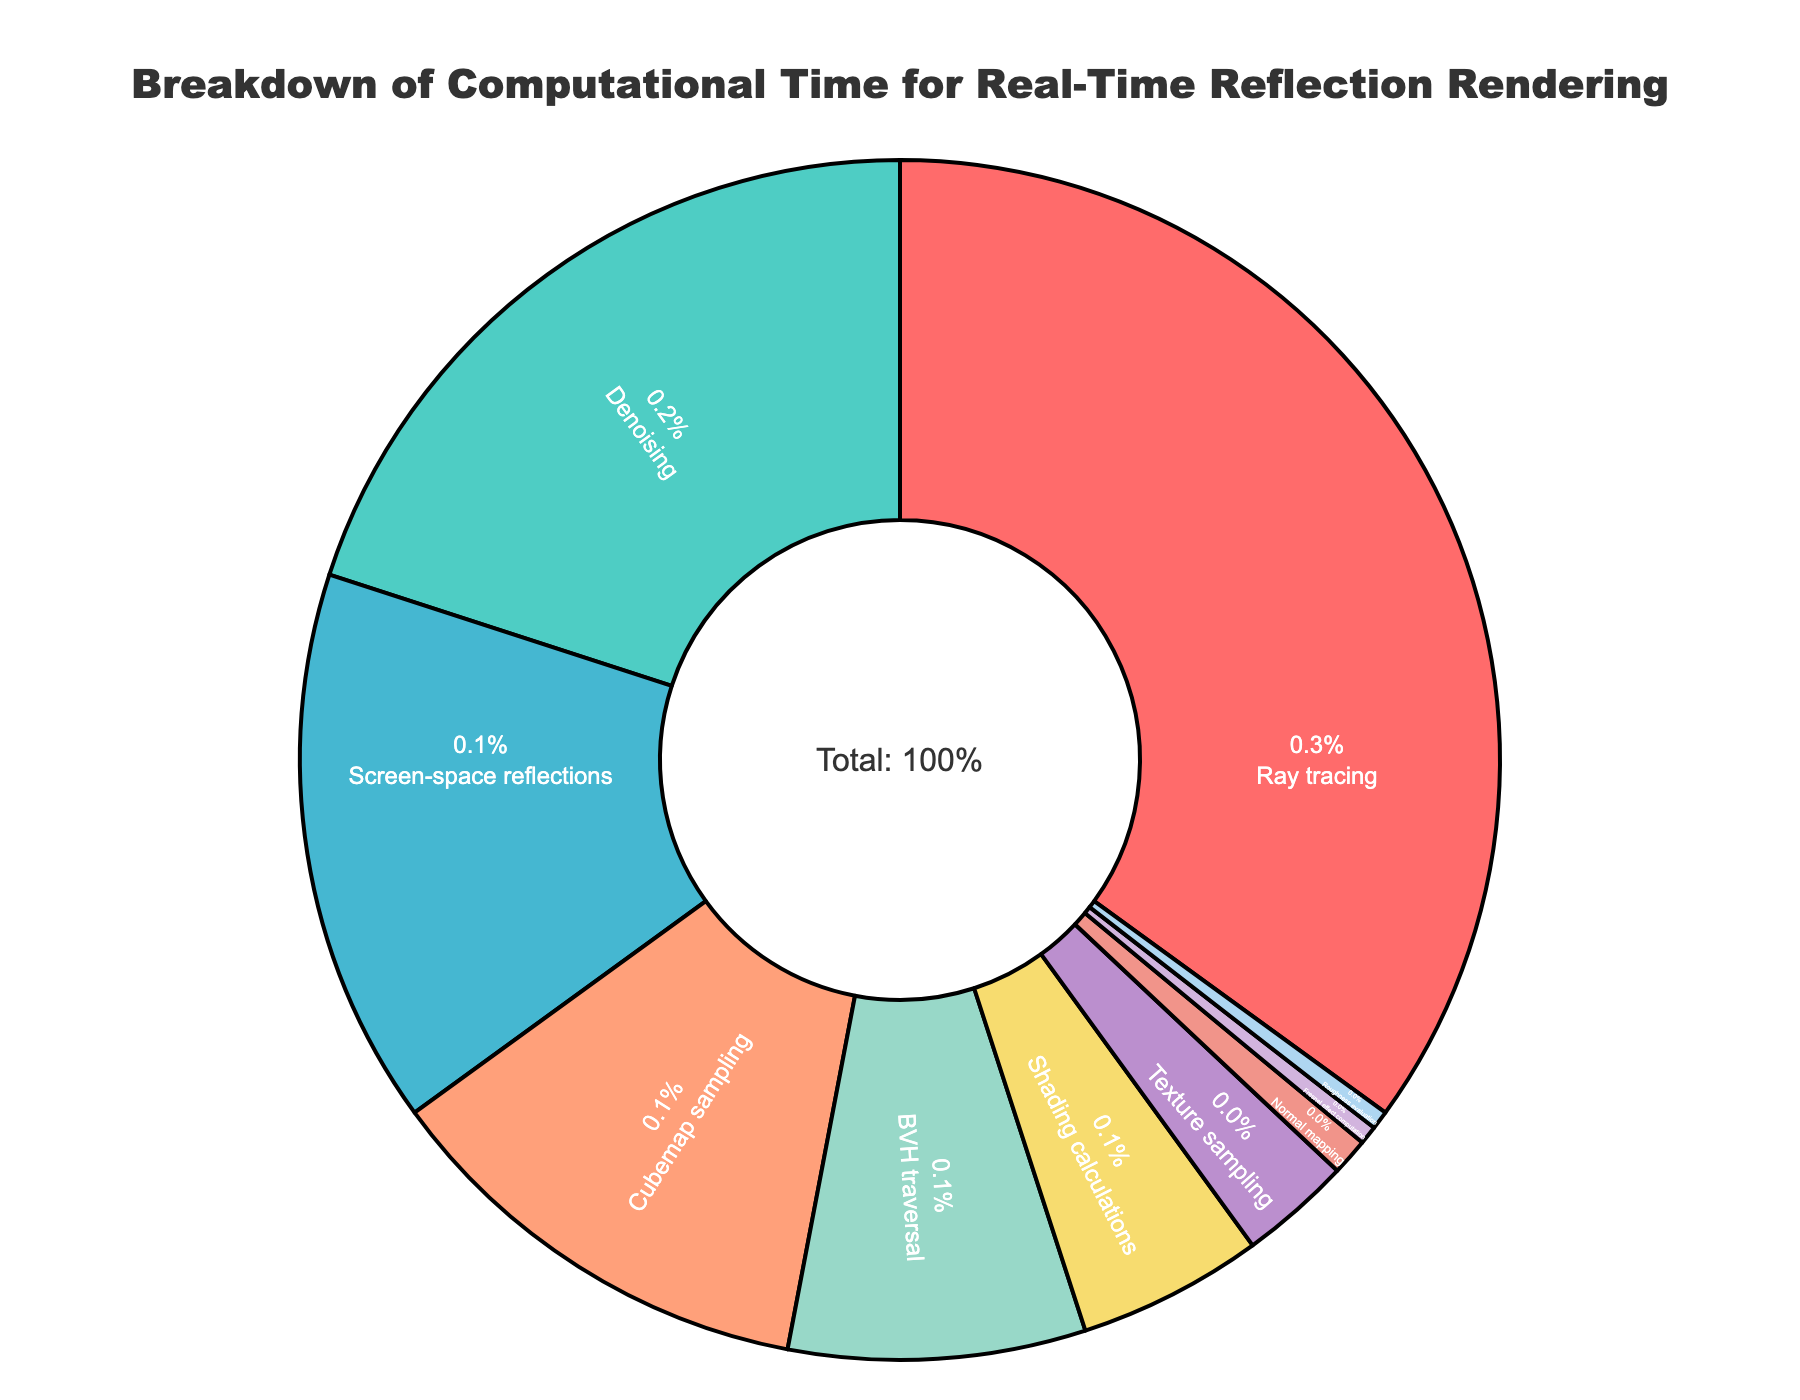What stage consumes the most computational time? The pie chart shows the percentage of computational time for each stage. The stage with the largest percentage slice is 'Ray tracing' at 35%.
Answer: Ray tracing Which stage takes less computational time, Denoising or Screen-space reflections? The pie chart shows 'Denoising' at 20% and 'Screen-space reflections' at 15%. By comparing these two percentages, it's clear that 'Screen-space reflections' takes less computational time than 'Denoising'.
Answer: Screen-space reflections What is the combined percentage of computational time for Cubemap sampling and BVH traversal? The pie chart shows that 'Cubemap sampling' takes 12% and 'BVH traversal' takes 8% of the computational time. Summing these percentages: 12% + 8% = 20%.
Answer: 20% Is Texture sampling more computationally expensive than Normal mapping? The pie chart shows 'Texture sampling' at 3% and 'Normal mapping' at 1%. Comparing these two percentages shows that 'Texture sampling' is more computationally expensive than 'Normal mapping'.
Answer: Yes, Texture sampling is more expensive What are the three stages with the smallest computational times? The pie chart displays smaller percentages for each stage. The three smallest slices are 'Normal mapping' at 1%, 'Fresnel effect computation' at 0.5%, and 'Roughness evaluation' also at 0.5%.
Answer: Normal mapping, Fresnel effect computation, Roughness evaluation How much more computational time does Shading calculations consume compared to Roughness evaluation? The pie chart shows 'Shading calculations' at 5% and 'Roughness evaluation' at 0.5%. Subtracting these percentages: 5% - 0.5% = 4.5%.
Answer: 4.5% What is the percentage difference between Ray tracing and Denoising? The pie chart shows 'Ray tracing' at 35% and 'Denoising' at 20%. The difference between these percentages is calculated as follows: 35% - 20% = 15%.
Answer: 15% What is the second most computationally expensive stage? The pie chart shows the percentages of each stage. The second-largest slice, following 'Ray tracing' at 35%, is 'Denoising' at 20%.
Answer: Denoising Is there a stage that uses exactly half a percent of computational time? The pie chart shows the percentage of computational time for each stage. Both 'Fresnel effect computation' and 'Roughness evaluation' have slices that are marked as 0.5%.
Answer: Yes 